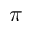<formula> <loc_0><loc_0><loc_500><loc_500>\pi</formula> 